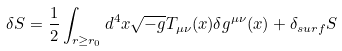<formula> <loc_0><loc_0><loc_500><loc_500>\delta S = \frac { 1 } { 2 } \int _ { r \geq r _ { 0 } } d ^ { 4 } x \sqrt { - g } T _ { \mu \nu } ( x ) \delta g ^ { \mu \nu } ( x ) + \delta _ { s u r f } S</formula> 